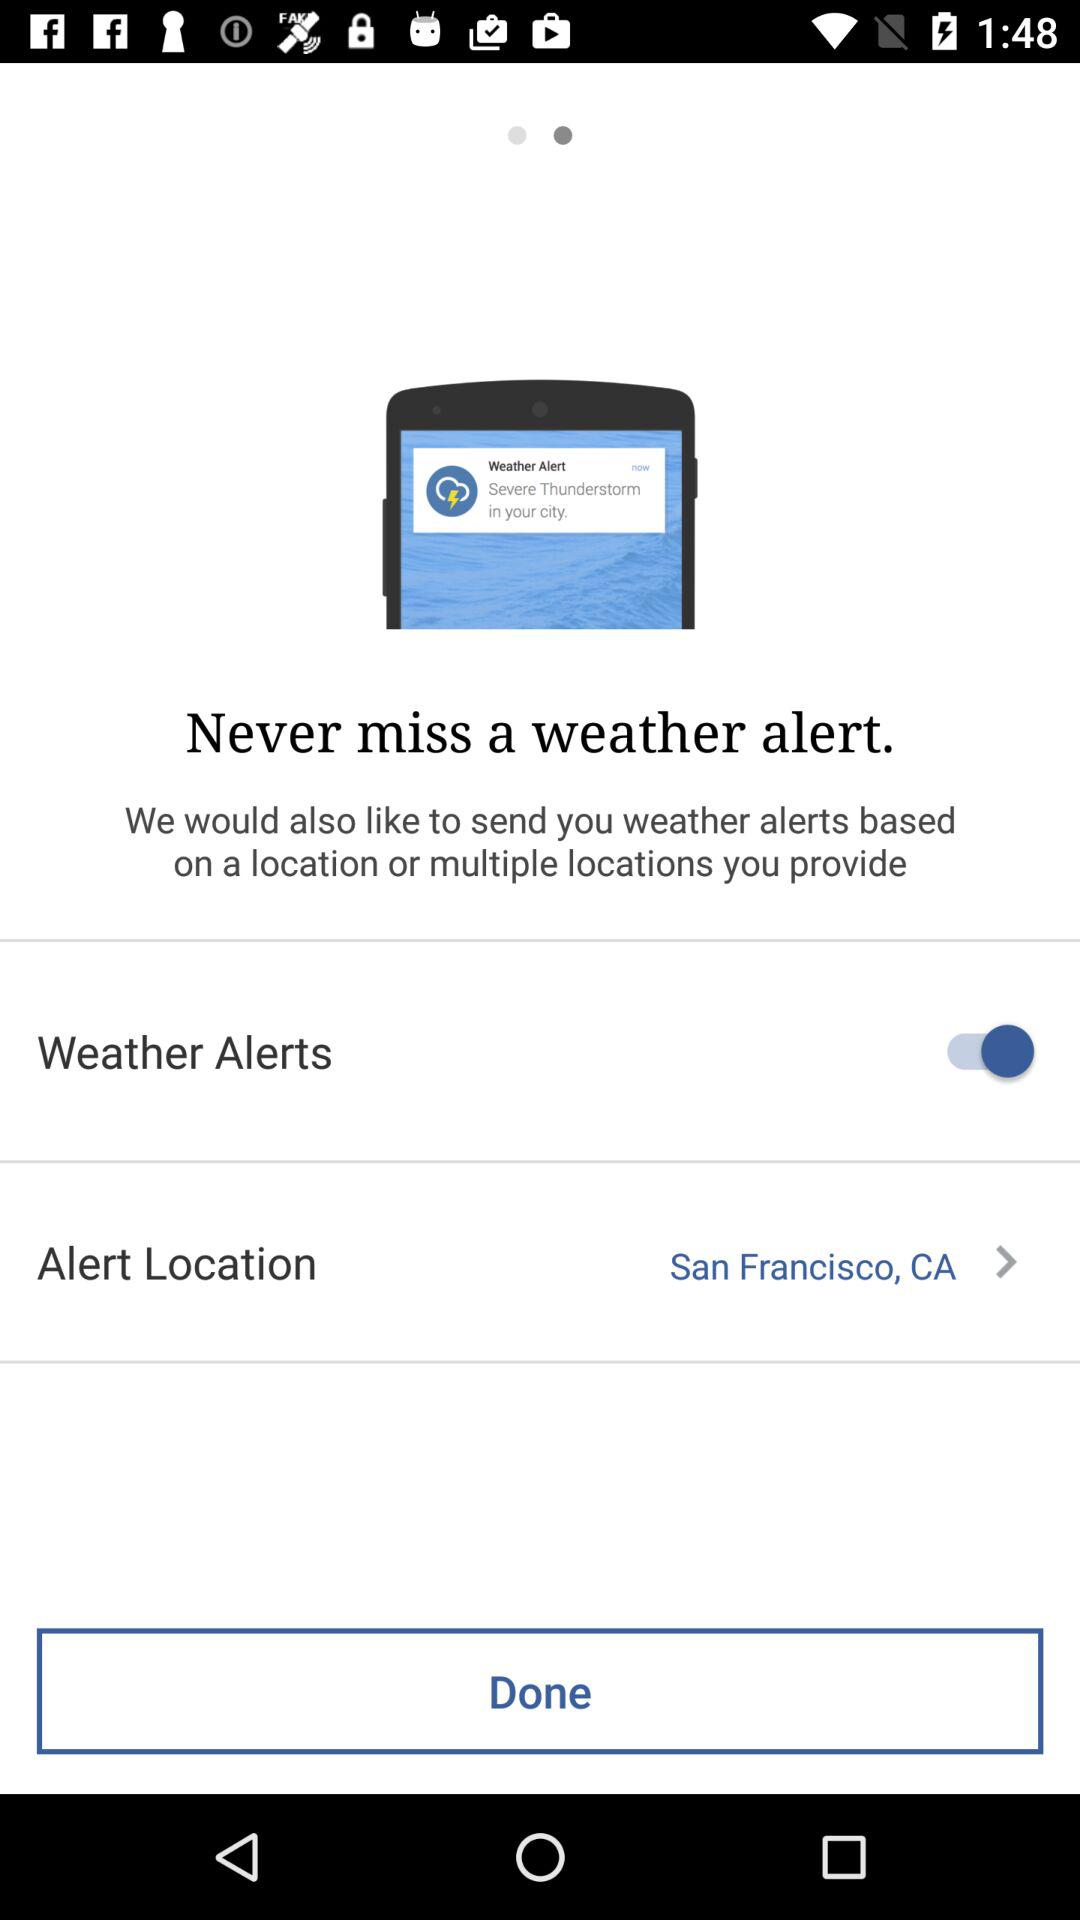What is the "Alert Location"? The "Alert Location" is San Francisco, CA. 